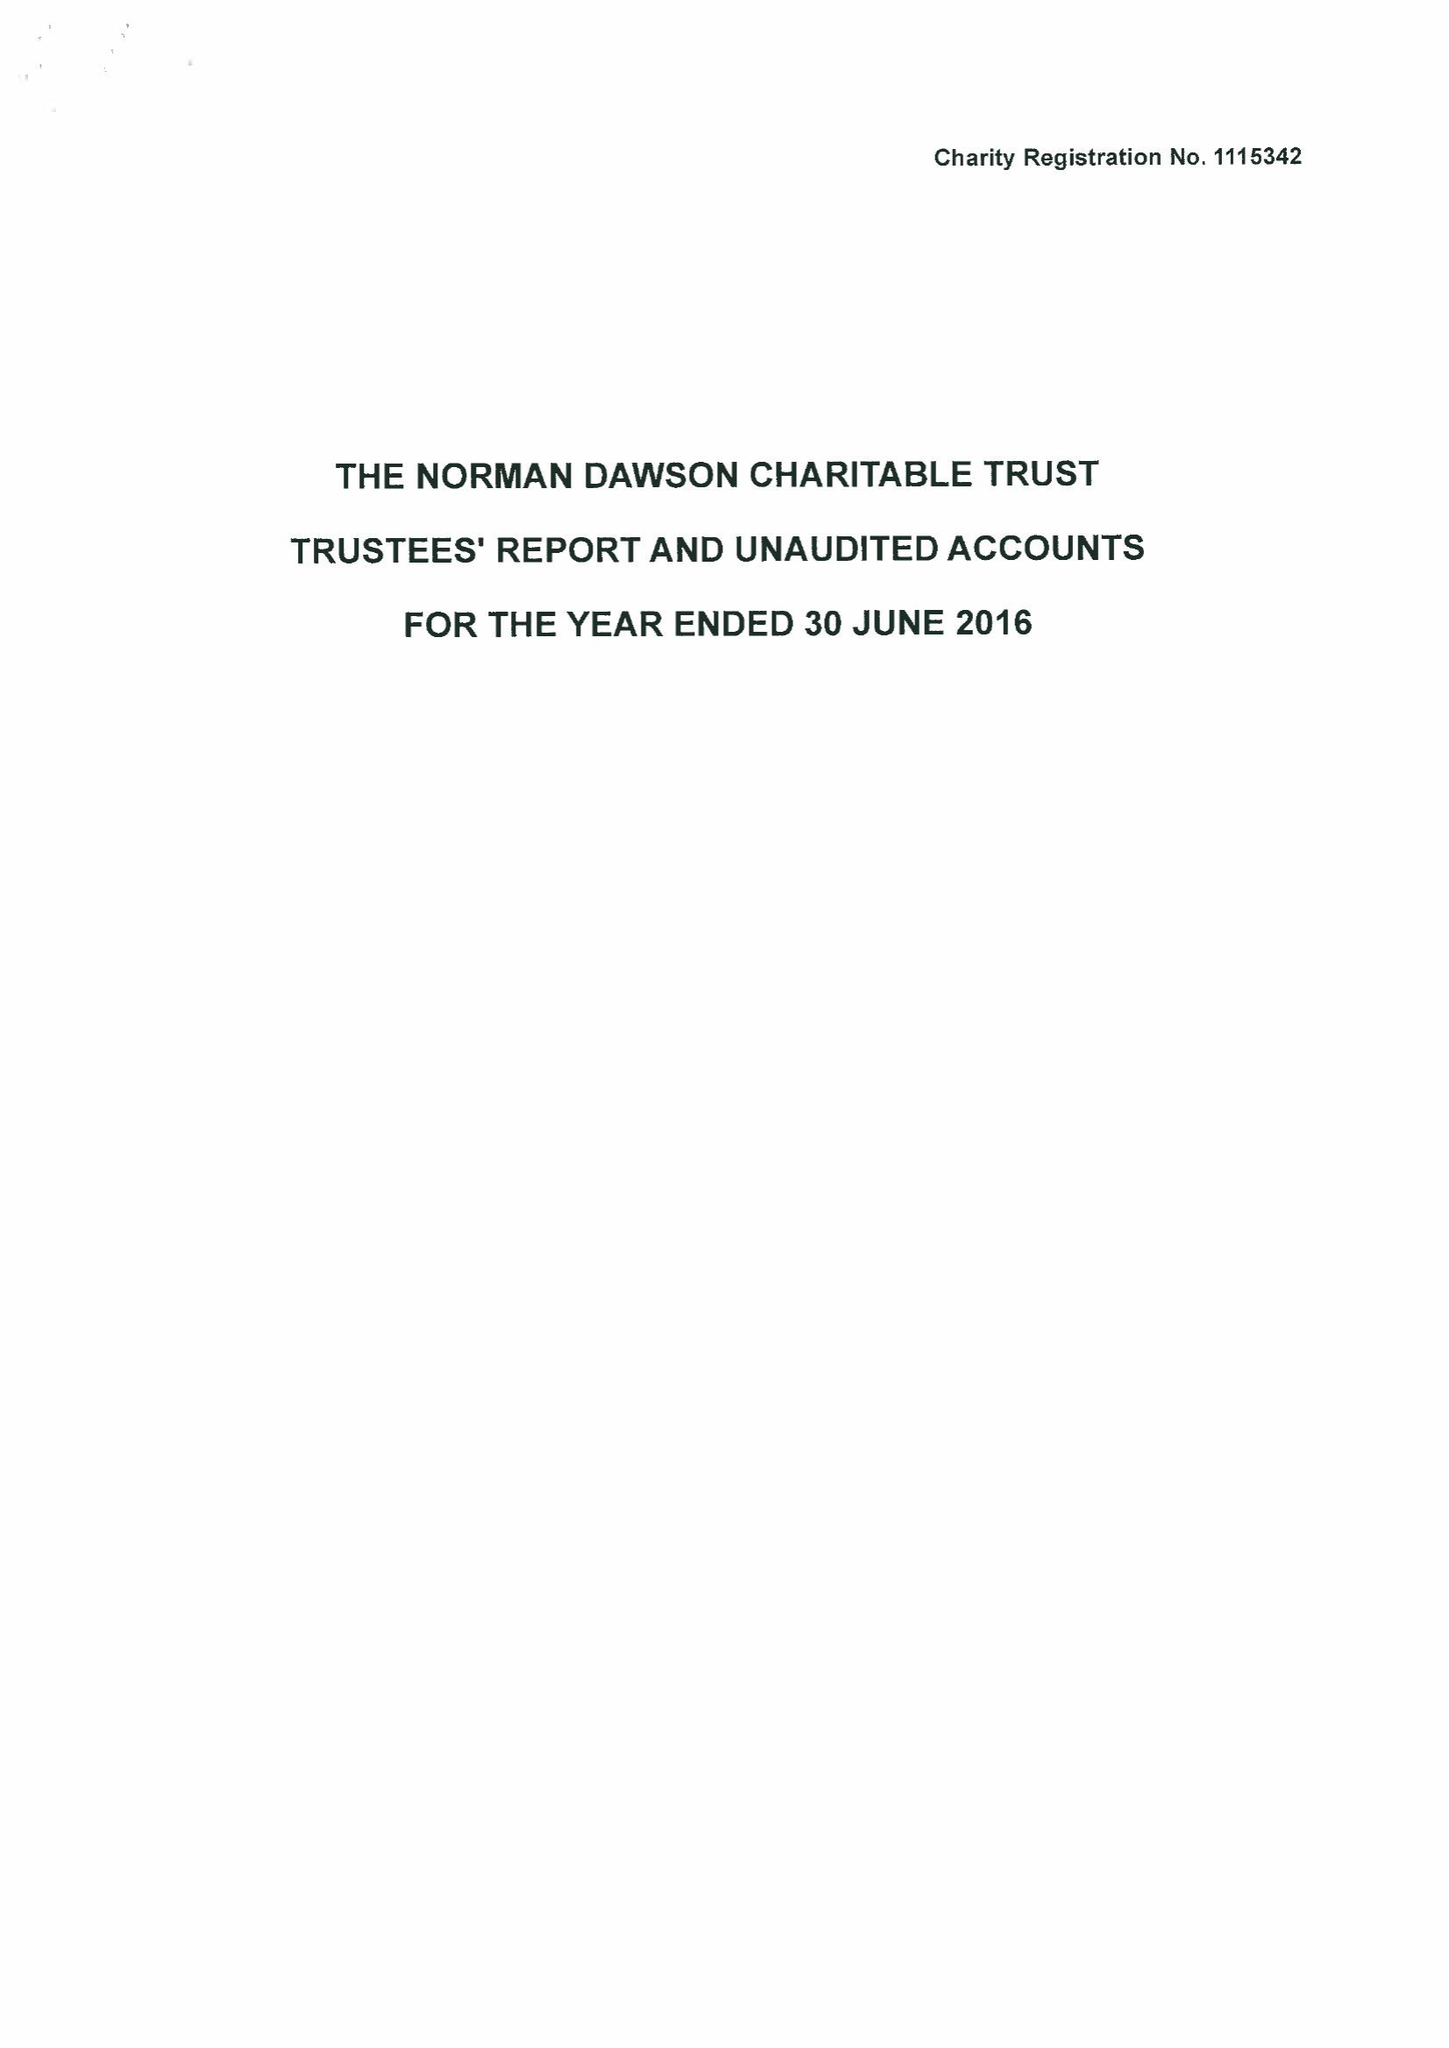What is the value for the report_date?
Answer the question using a single word or phrase. 2016-06-30 